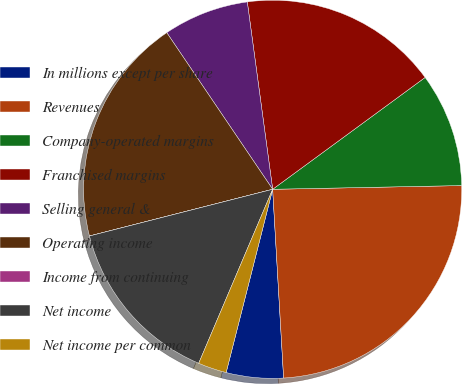<chart> <loc_0><loc_0><loc_500><loc_500><pie_chart><fcel>In millions except per share<fcel>Revenues<fcel>Company-operated margins<fcel>Franchised margins<fcel>Selling general &<fcel>Operating income<fcel>Income from continuing<fcel>Net income<fcel>Net income per common<nl><fcel>4.88%<fcel>24.39%<fcel>9.76%<fcel>17.07%<fcel>7.32%<fcel>19.51%<fcel>0.0%<fcel>14.63%<fcel>2.44%<nl></chart> 